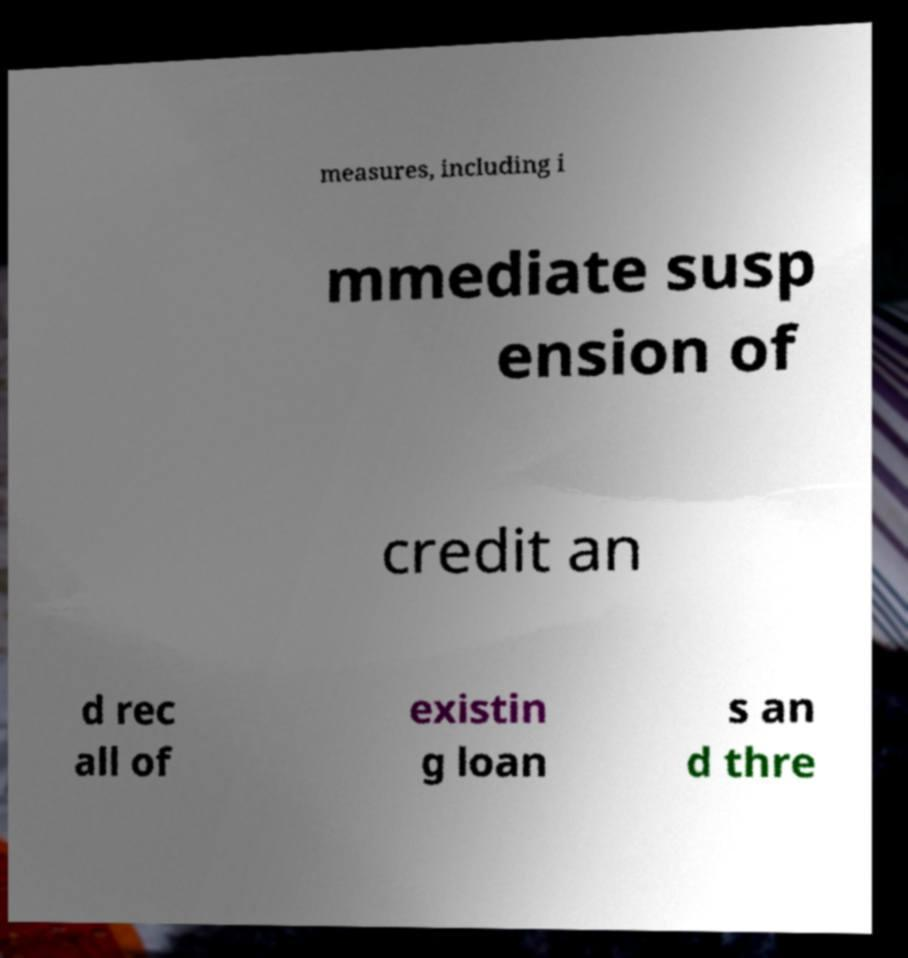Can you accurately transcribe the text from the provided image for me? measures, including i mmediate susp ension of credit an d rec all of existin g loan s an d thre 